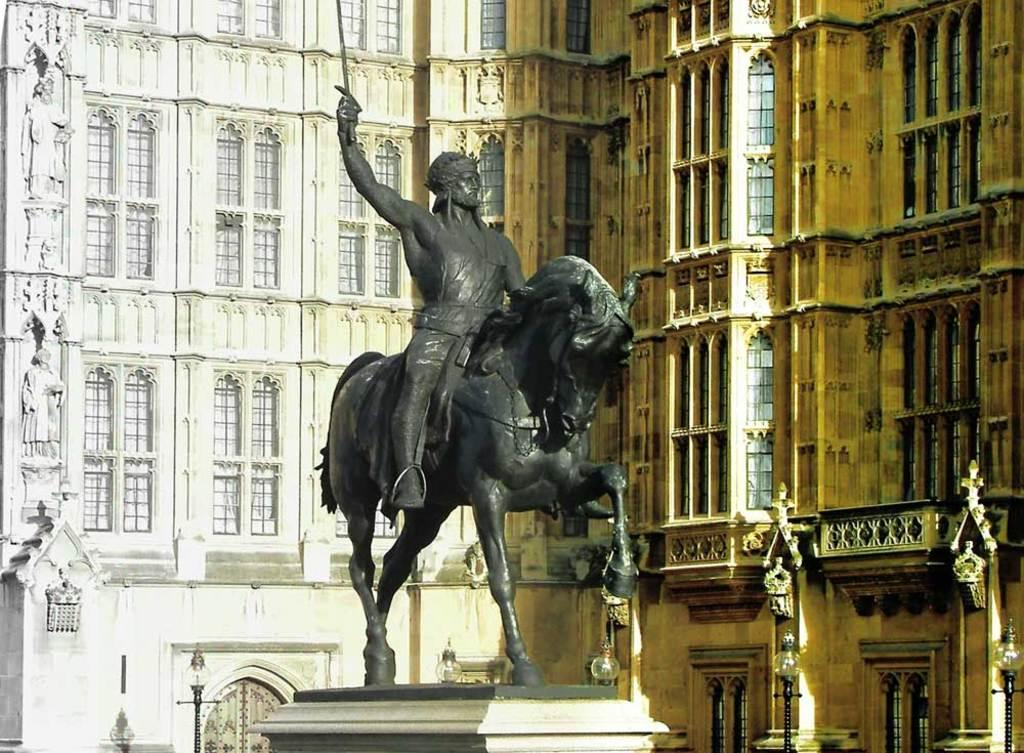What is the main subject of the image? There is a statue in the image. What can be seen in the background of the image? There are street lights and buildings in the background of the image. What feature do the buildings in the image have? The buildings in the image have windows. How many tickets are visible on the statue in the image? There are no tickets present on the statue in the image. What type of flag can be seen flying near the statue in the image? There is no flag visible near the statue in the image. 